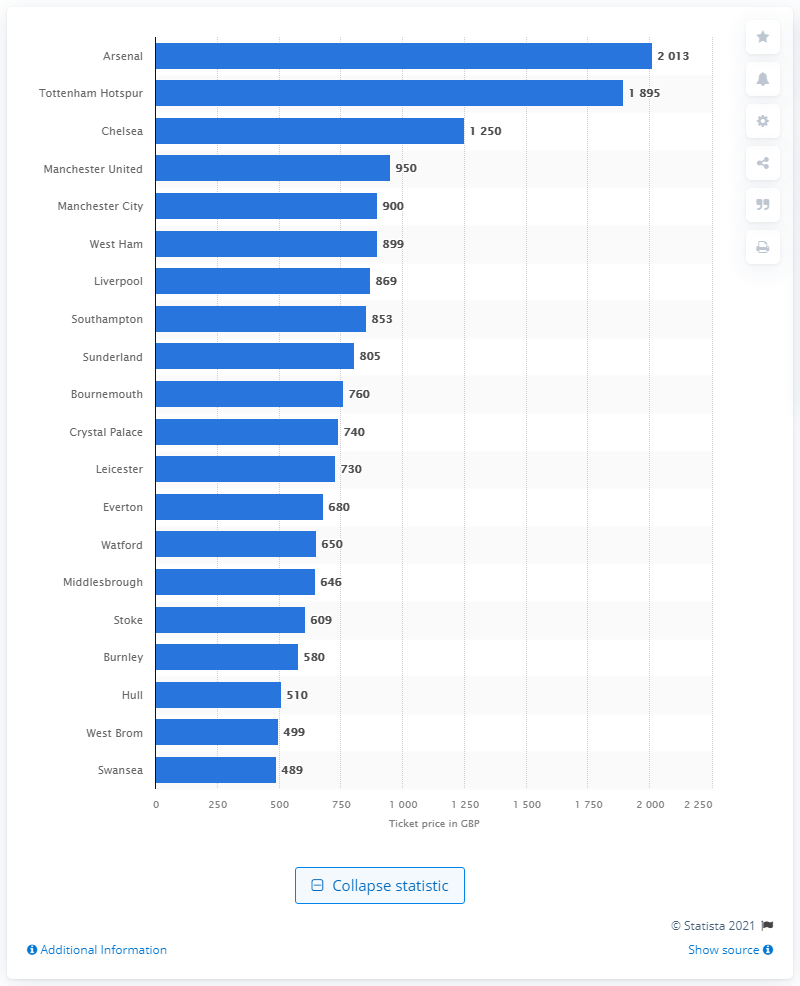Point out several critical features in this image. Manchester City sells the most expensive season ticket for 325 British pounds. 